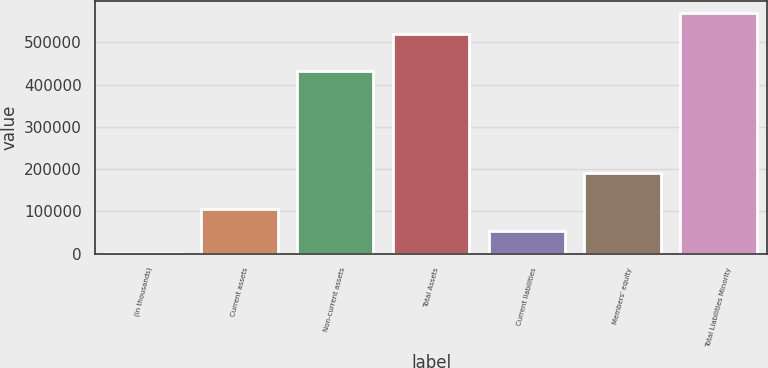Convert chart. <chart><loc_0><loc_0><loc_500><loc_500><bar_chart><fcel>(in thousands)<fcel>Current assets<fcel>Non-current assets<fcel>Total Assets<fcel>Current liabilities<fcel>Members' equity<fcel>Total Liabilities Minority<nl><fcel>2001<fcel>105330<fcel>432431<fcel>518644<fcel>53665.3<fcel>190136<fcel>570308<nl></chart> 